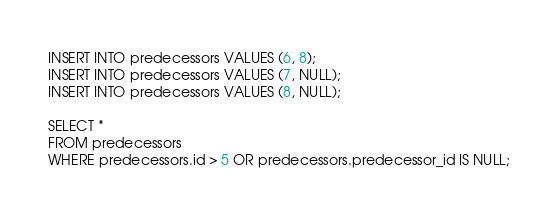<code> <loc_0><loc_0><loc_500><loc_500><_SQL_>INSERT INTO predecessors VALUES (6, 8);
INSERT INTO predecessors VALUES (7, NULL);
INSERT INTO predecessors VALUES (8, NULL);

SELECT *
FROM predecessors
WHERE predecessors.id > 5 OR predecessors.predecessor_id IS NULL;
</code> 